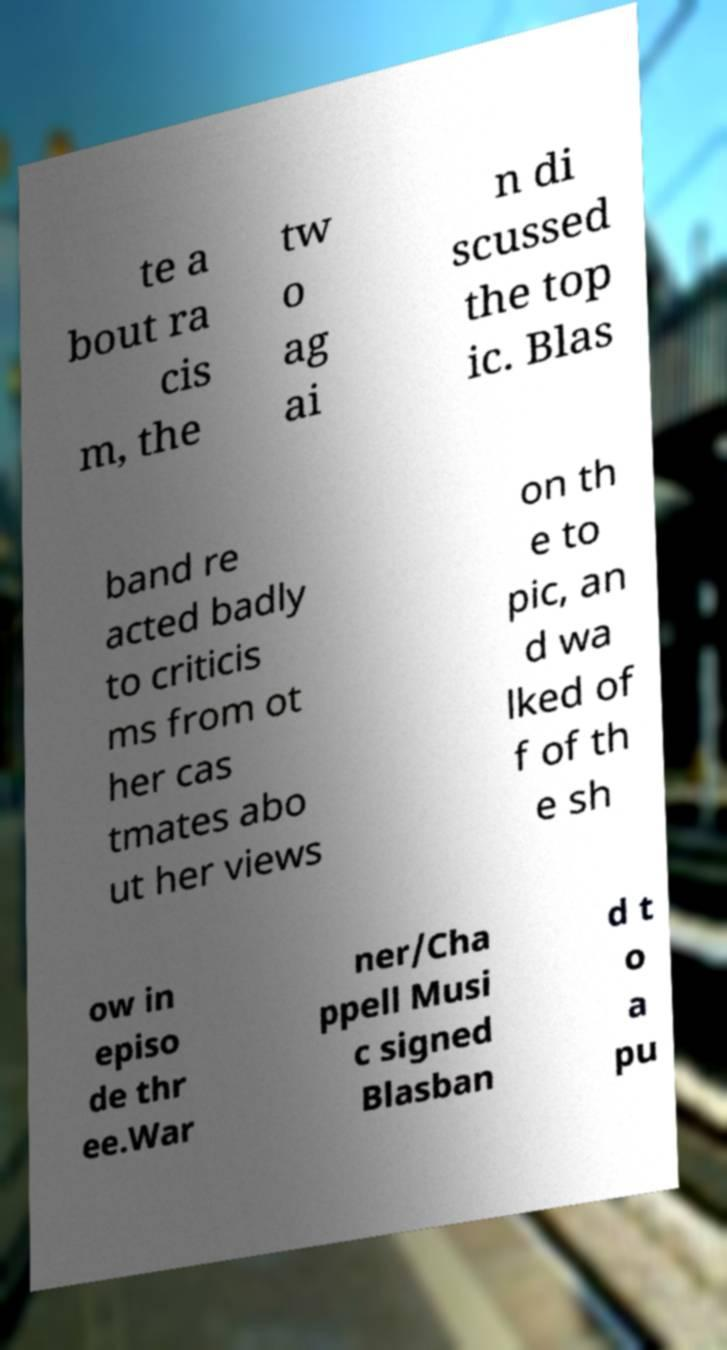Please read and relay the text visible in this image. What does it say? te a bout ra cis m, the tw o ag ai n di scussed the top ic. Blas band re acted badly to criticis ms from ot her cas tmates abo ut her views on th e to pic, an d wa lked of f of th e sh ow in episo de thr ee.War ner/Cha ppell Musi c signed Blasban d t o a pu 